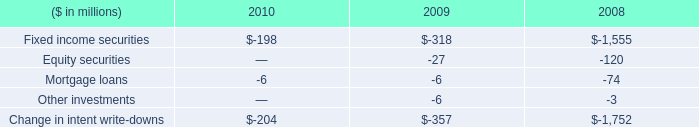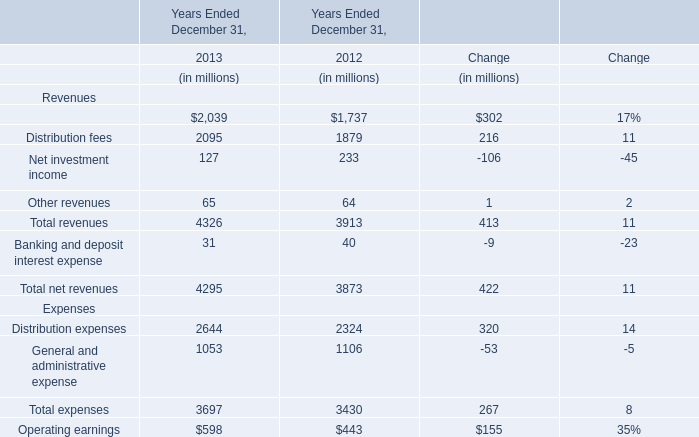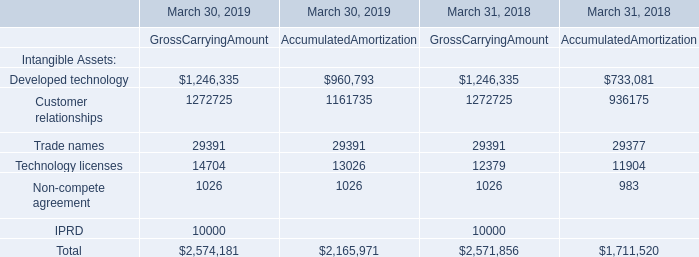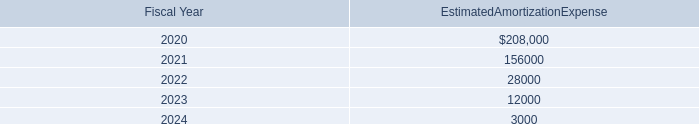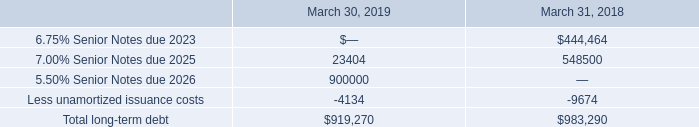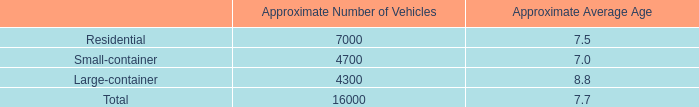What will Management and financial advice fees be like in 2014 if it continues to grow at the same rate as it did in 2013? (in dollars in millions) 
Computations: (2039 * (1 + (17 / 100)))
Answer: 2385.63. 